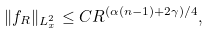<formula> <loc_0><loc_0><loc_500><loc_500>\| f _ { R } \| _ { L ^ { 2 } _ { x } } \leq C R ^ { ( \alpha ( n - 1 ) + 2 \gamma ) / 4 } ,</formula> 